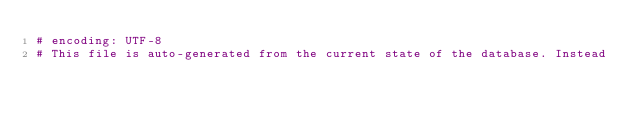Convert code to text. <code><loc_0><loc_0><loc_500><loc_500><_Ruby_># encoding: UTF-8
# This file is auto-generated from the current state of the database. Instead</code> 